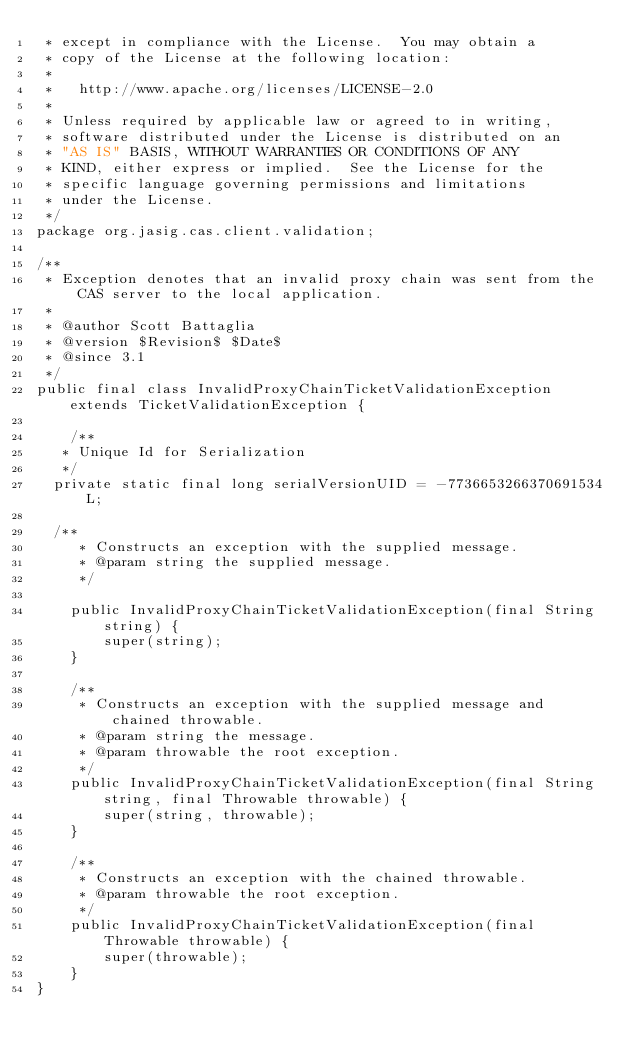<code> <loc_0><loc_0><loc_500><loc_500><_Java_> * except in compliance with the License.  You may obtain a
 * copy of the License at the following location:
 *
 *   http://www.apache.org/licenses/LICENSE-2.0
 *
 * Unless required by applicable law or agreed to in writing,
 * software distributed under the License is distributed on an
 * "AS IS" BASIS, WITHOUT WARRANTIES OR CONDITIONS OF ANY
 * KIND, either express or implied.  See the License for the
 * specific language governing permissions and limitations
 * under the License.
 */
package org.jasig.cas.client.validation;

/**
 * Exception denotes that an invalid proxy chain was sent from the CAS server to the local application. 
 *
 * @author Scott Battaglia
 * @version $Revision$ $Date$
 * @since 3.1
 */
public final class InvalidProxyChainTicketValidationException extends TicketValidationException {

    /**
	 * Unique Id for Serialization
	 */
	private static final long serialVersionUID = -7736653266370691534L;

	/**
     * Constructs an exception with the supplied message.
     * @param string the supplied message.
     */

    public InvalidProxyChainTicketValidationException(final String string) {
        super(string);
    }

    /**
     * Constructs an exception with the supplied message and chained throwable.
     * @param string the message.
     * @param throwable the root exception.
     */
    public InvalidProxyChainTicketValidationException(final String string, final Throwable throwable) {
        super(string, throwable);
    }

    /**
     * Constructs an exception with the chained throwable.
     * @param throwable the root exception.
     */
    public InvalidProxyChainTicketValidationException(final Throwable throwable) {
        super(throwable);
    }
}
</code> 